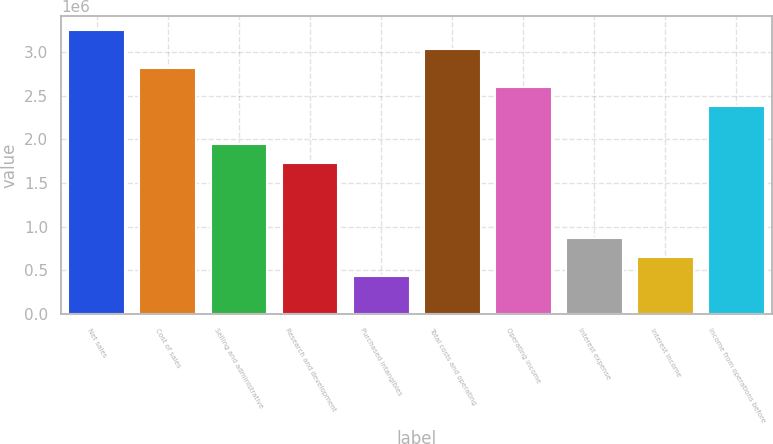Convert chart to OTSL. <chart><loc_0><loc_0><loc_500><loc_500><bar_chart><fcel>Net sales<fcel>Cost of sales<fcel>Selling and administrative<fcel>Research and development<fcel>Purchased intangibles<fcel>Total costs and operating<fcel>Operating income<fcel>Interest expense<fcel>Interest income<fcel>Income from operations before<nl><fcel>3.25113e+06<fcel>2.81765e+06<fcel>1.95068e+06<fcel>1.73394e+06<fcel>433490<fcel>3.03439e+06<fcel>2.60091e+06<fcel>866973<fcel>650231<fcel>2.38416e+06<nl></chart> 